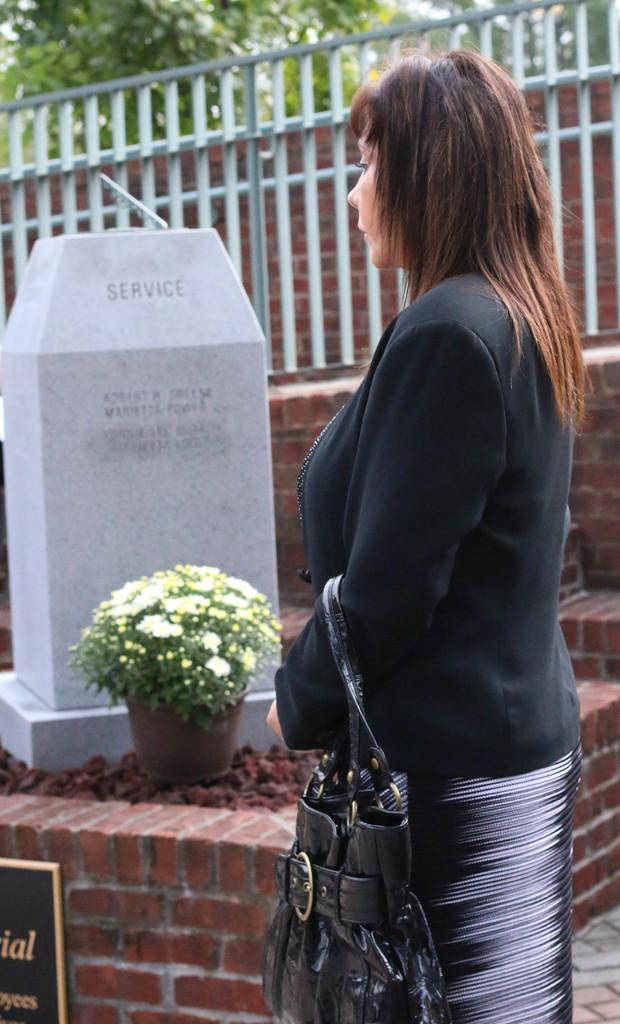Who is present in the image? There is a lady in the image. What is the lady holding in the image? The lady is holding a bag. What can be seen in the background of the image? There is a flower pot, a wall, and a fence in the background of the image. What color are the lady's toes in the image? There is no information about the lady's toes in the image, so we cannot determine their color. 